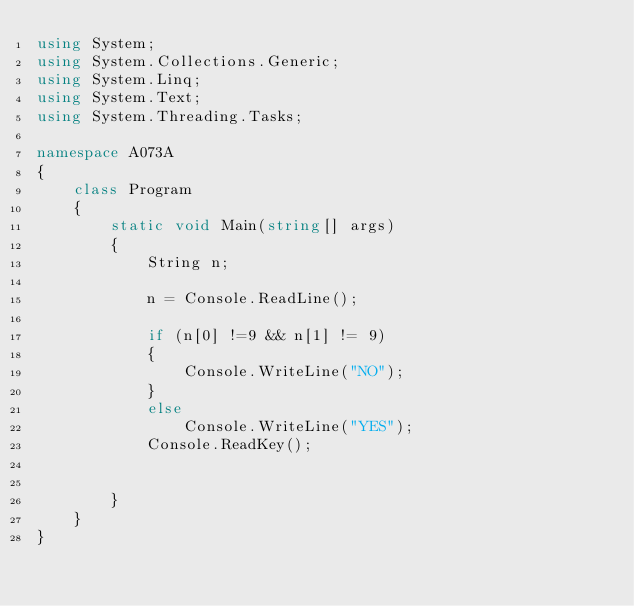Convert code to text. <code><loc_0><loc_0><loc_500><loc_500><_C#_>using System;
using System.Collections.Generic;
using System.Linq;
using System.Text;
using System.Threading.Tasks;

namespace A073A
{
    class Program
    {
        static void Main(string[] args)
        {
            String n;

            n = Console.ReadLine();

            if (n[0] !=9 && n[1] != 9)
            {
                Console.WriteLine("NO");
            }
            else
                Console.WriteLine("YES");
            Console.ReadKey();


        }
    }
}
</code> 